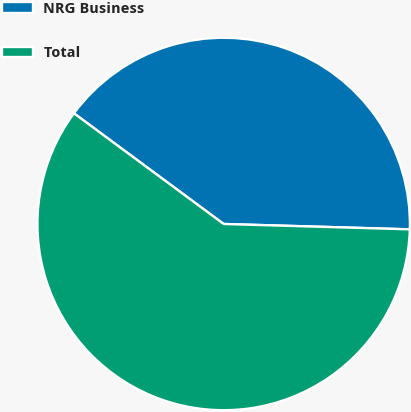Convert chart. <chart><loc_0><loc_0><loc_500><loc_500><pie_chart><fcel>NRG Business<fcel>Total<nl><fcel>40.33%<fcel>59.67%<nl></chart> 